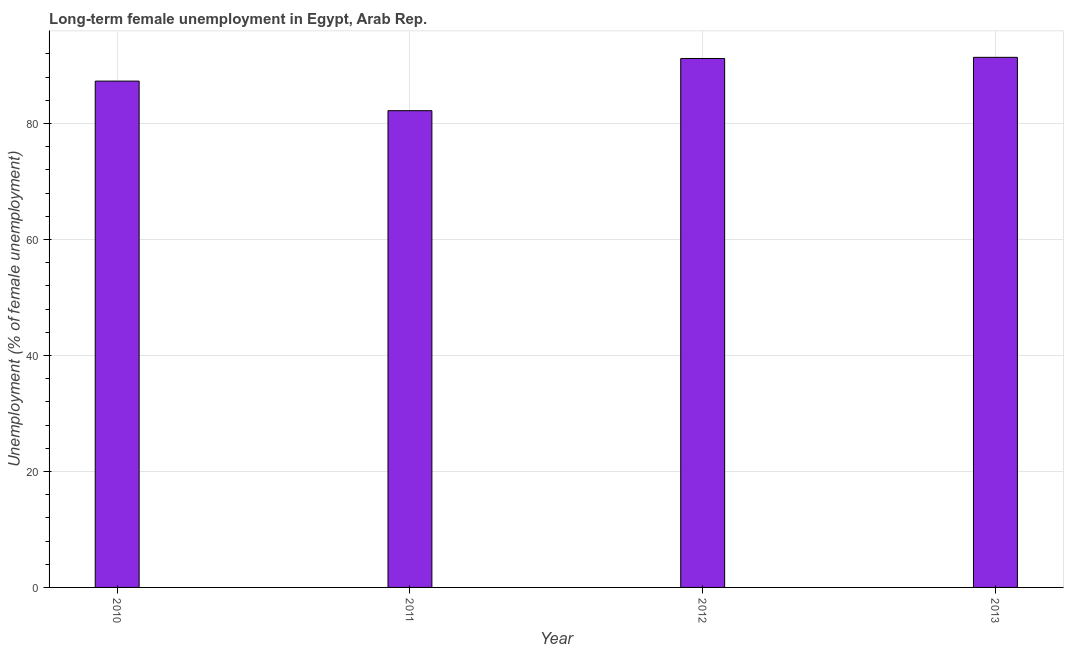Does the graph contain grids?
Your answer should be compact. Yes. What is the title of the graph?
Your answer should be compact. Long-term female unemployment in Egypt, Arab Rep. What is the label or title of the Y-axis?
Provide a short and direct response. Unemployment (% of female unemployment). What is the long-term female unemployment in 2012?
Offer a terse response. 91.2. Across all years, what is the maximum long-term female unemployment?
Offer a very short reply. 91.4. Across all years, what is the minimum long-term female unemployment?
Make the answer very short. 82.2. In which year was the long-term female unemployment maximum?
Keep it short and to the point. 2013. What is the sum of the long-term female unemployment?
Your answer should be very brief. 352.1. What is the average long-term female unemployment per year?
Offer a terse response. 88.03. What is the median long-term female unemployment?
Keep it short and to the point. 89.25. In how many years, is the long-term female unemployment greater than 60 %?
Your response must be concise. 4. Is the difference between the long-term female unemployment in 2010 and 2012 greater than the difference between any two years?
Your response must be concise. No. What is the difference between the highest and the second highest long-term female unemployment?
Ensure brevity in your answer.  0.2. How many bars are there?
Make the answer very short. 4. Are all the bars in the graph horizontal?
Give a very brief answer. No. How many years are there in the graph?
Offer a terse response. 4. What is the difference between two consecutive major ticks on the Y-axis?
Offer a very short reply. 20. Are the values on the major ticks of Y-axis written in scientific E-notation?
Offer a very short reply. No. What is the Unemployment (% of female unemployment) in 2010?
Provide a succinct answer. 87.3. What is the Unemployment (% of female unemployment) of 2011?
Ensure brevity in your answer.  82.2. What is the Unemployment (% of female unemployment) in 2012?
Your answer should be very brief. 91.2. What is the Unemployment (% of female unemployment) of 2013?
Your response must be concise. 91.4. What is the difference between the Unemployment (% of female unemployment) in 2010 and 2011?
Make the answer very short. 5.1. What is the difference between the Unemployment (% of female unemployment) in 2010 and 2012?
Provide a succinct answer. -3.9. What is the difference between the Unemployment (% of female unemployment) in 2012 and 2013?
Your answer should be very brief. -0.2. What is the ratio of the Unemployment (% of female unemployment) in 2010 to that in 2011?
Your response must be concise. 1.06. What is the ratio of the Unemployment (% of female unemployment) in 2010 to that in 2013?
Your answer should be compact. 0.95. What is the ratio of the Unemployment (% of female unemployment) in 2011 to that in 2012?
Make the answer very short. 0.9. What is the ratio of the Unemployment (% of female unemployment) in 2011 to that in 2013?
Provide a short and direct response. 0.9. What is the ratio of the Unemployment (% of female unemployment) in 2012 to that in 2013?
Your response must be concise. 1. 